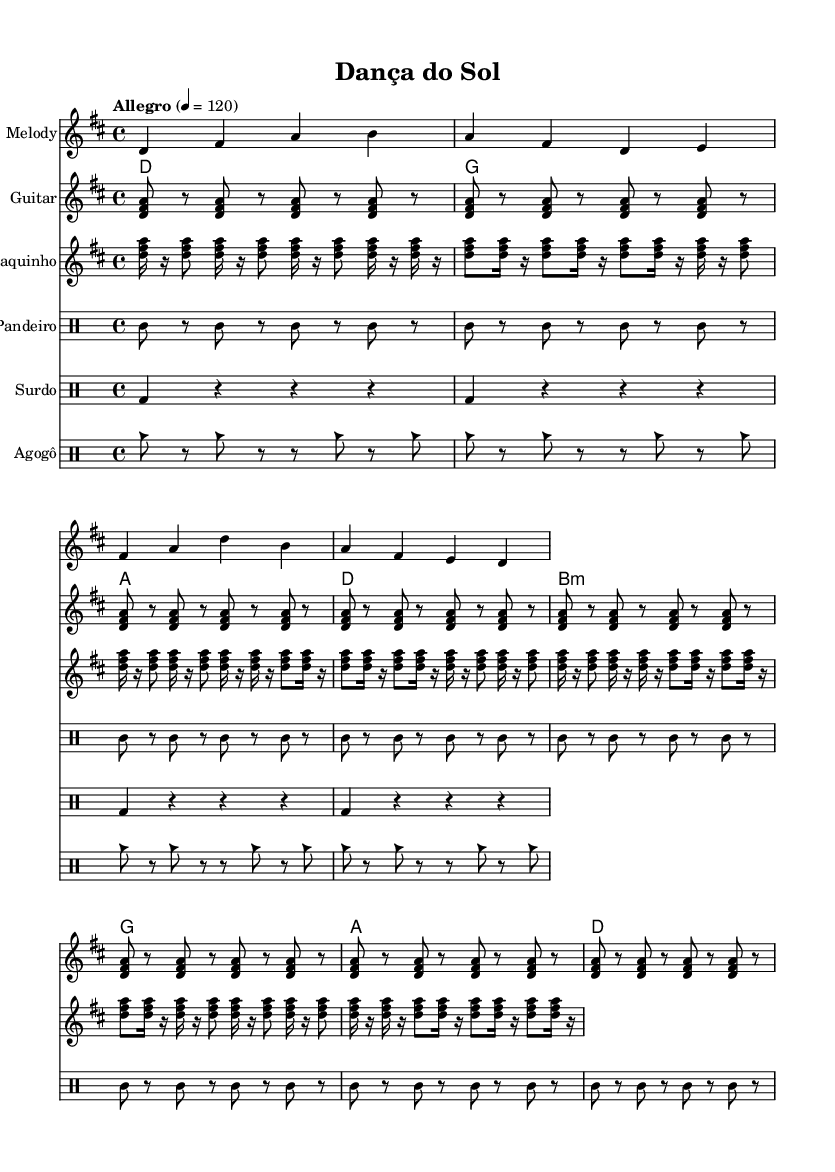What is the key signature of this music? The key signature is D major, which has two sharps (F# and C#). This can be deduced from the key indication at the beginning of the score, denoted by the symbol associated with D major.
Answer: D major What is the time signature of this music? The time signature is 4/4, as indicated at the start of the score. This tells us that each measure contains four beats and that the quarter note gets one beat.
Answer: 4/4 What is the tempo marking of this piece? The tempo marking is "Allegro," with a metronome marking of 120, suggesting a fast and lively pace. This information can be found in the tempo indication located at the beginning of the score.
Answer: Allegro How many measures does the melody contain? The melody consists of 8 measures, as shown by counting each vertical barline in the melody staff. Each barline indicates the end of one measure and the beginning of another, leading to a total of eight.
Answer: 8 measures What instruments are featured in this piece? The instruments featured include Melody, Guitar, Cavaquinho, Pandeiro, Surdo, and Agogô. These can be identified by the corresponding staff names labeled at the left of each musical staff.
Answer: Melody, Guitar, Cavaquinho, Pandeiro, Surdo, Agogô Which rhythm is used for the Pandeiro? The rhythm for the Pandeiro consists of a repeated pattern of tambourine strokes with rests. This is clearly indicated in the drum staff associated with the Pandeiro, where "tamb8" denotes a tambourine stroke, followed by rests.
Answer: tamb What type of musical piece is "Dança do Sol"? "Dança do Sol" fits the category of upbeat Latin American folk music, characterized by its lively rhythms and instrumentation, which is typical for folk tunes that emphasize intricate guitar work and vibrant percussion. This piece is composed with a lively tempo and is structured to highlight these characteristics.
Answer: Upbeat Latin American folk music 